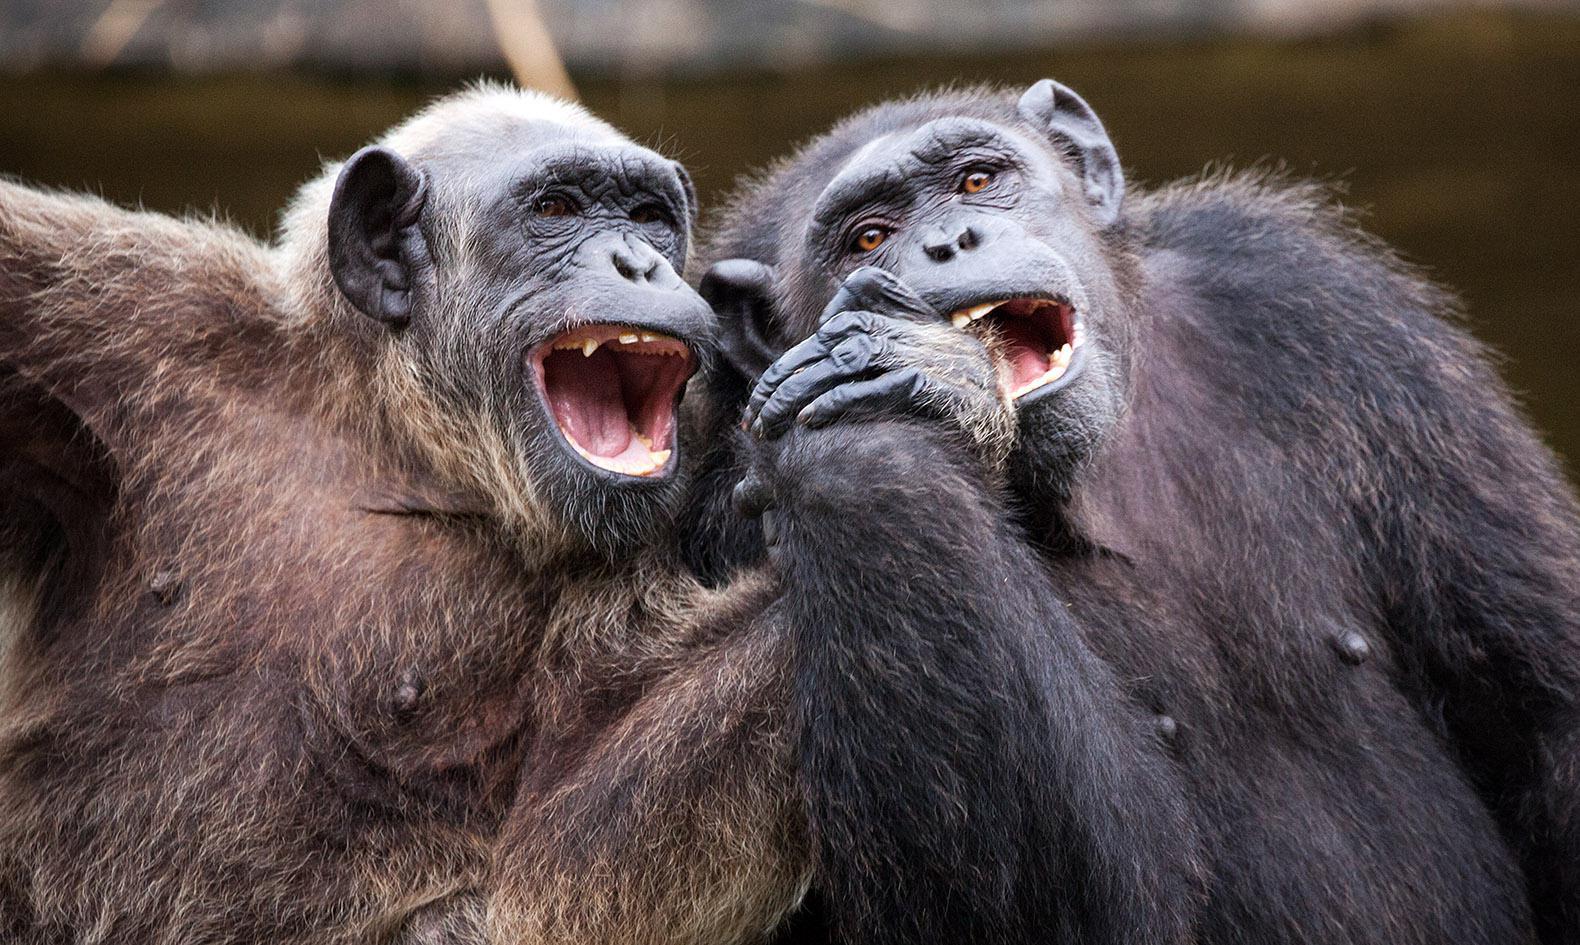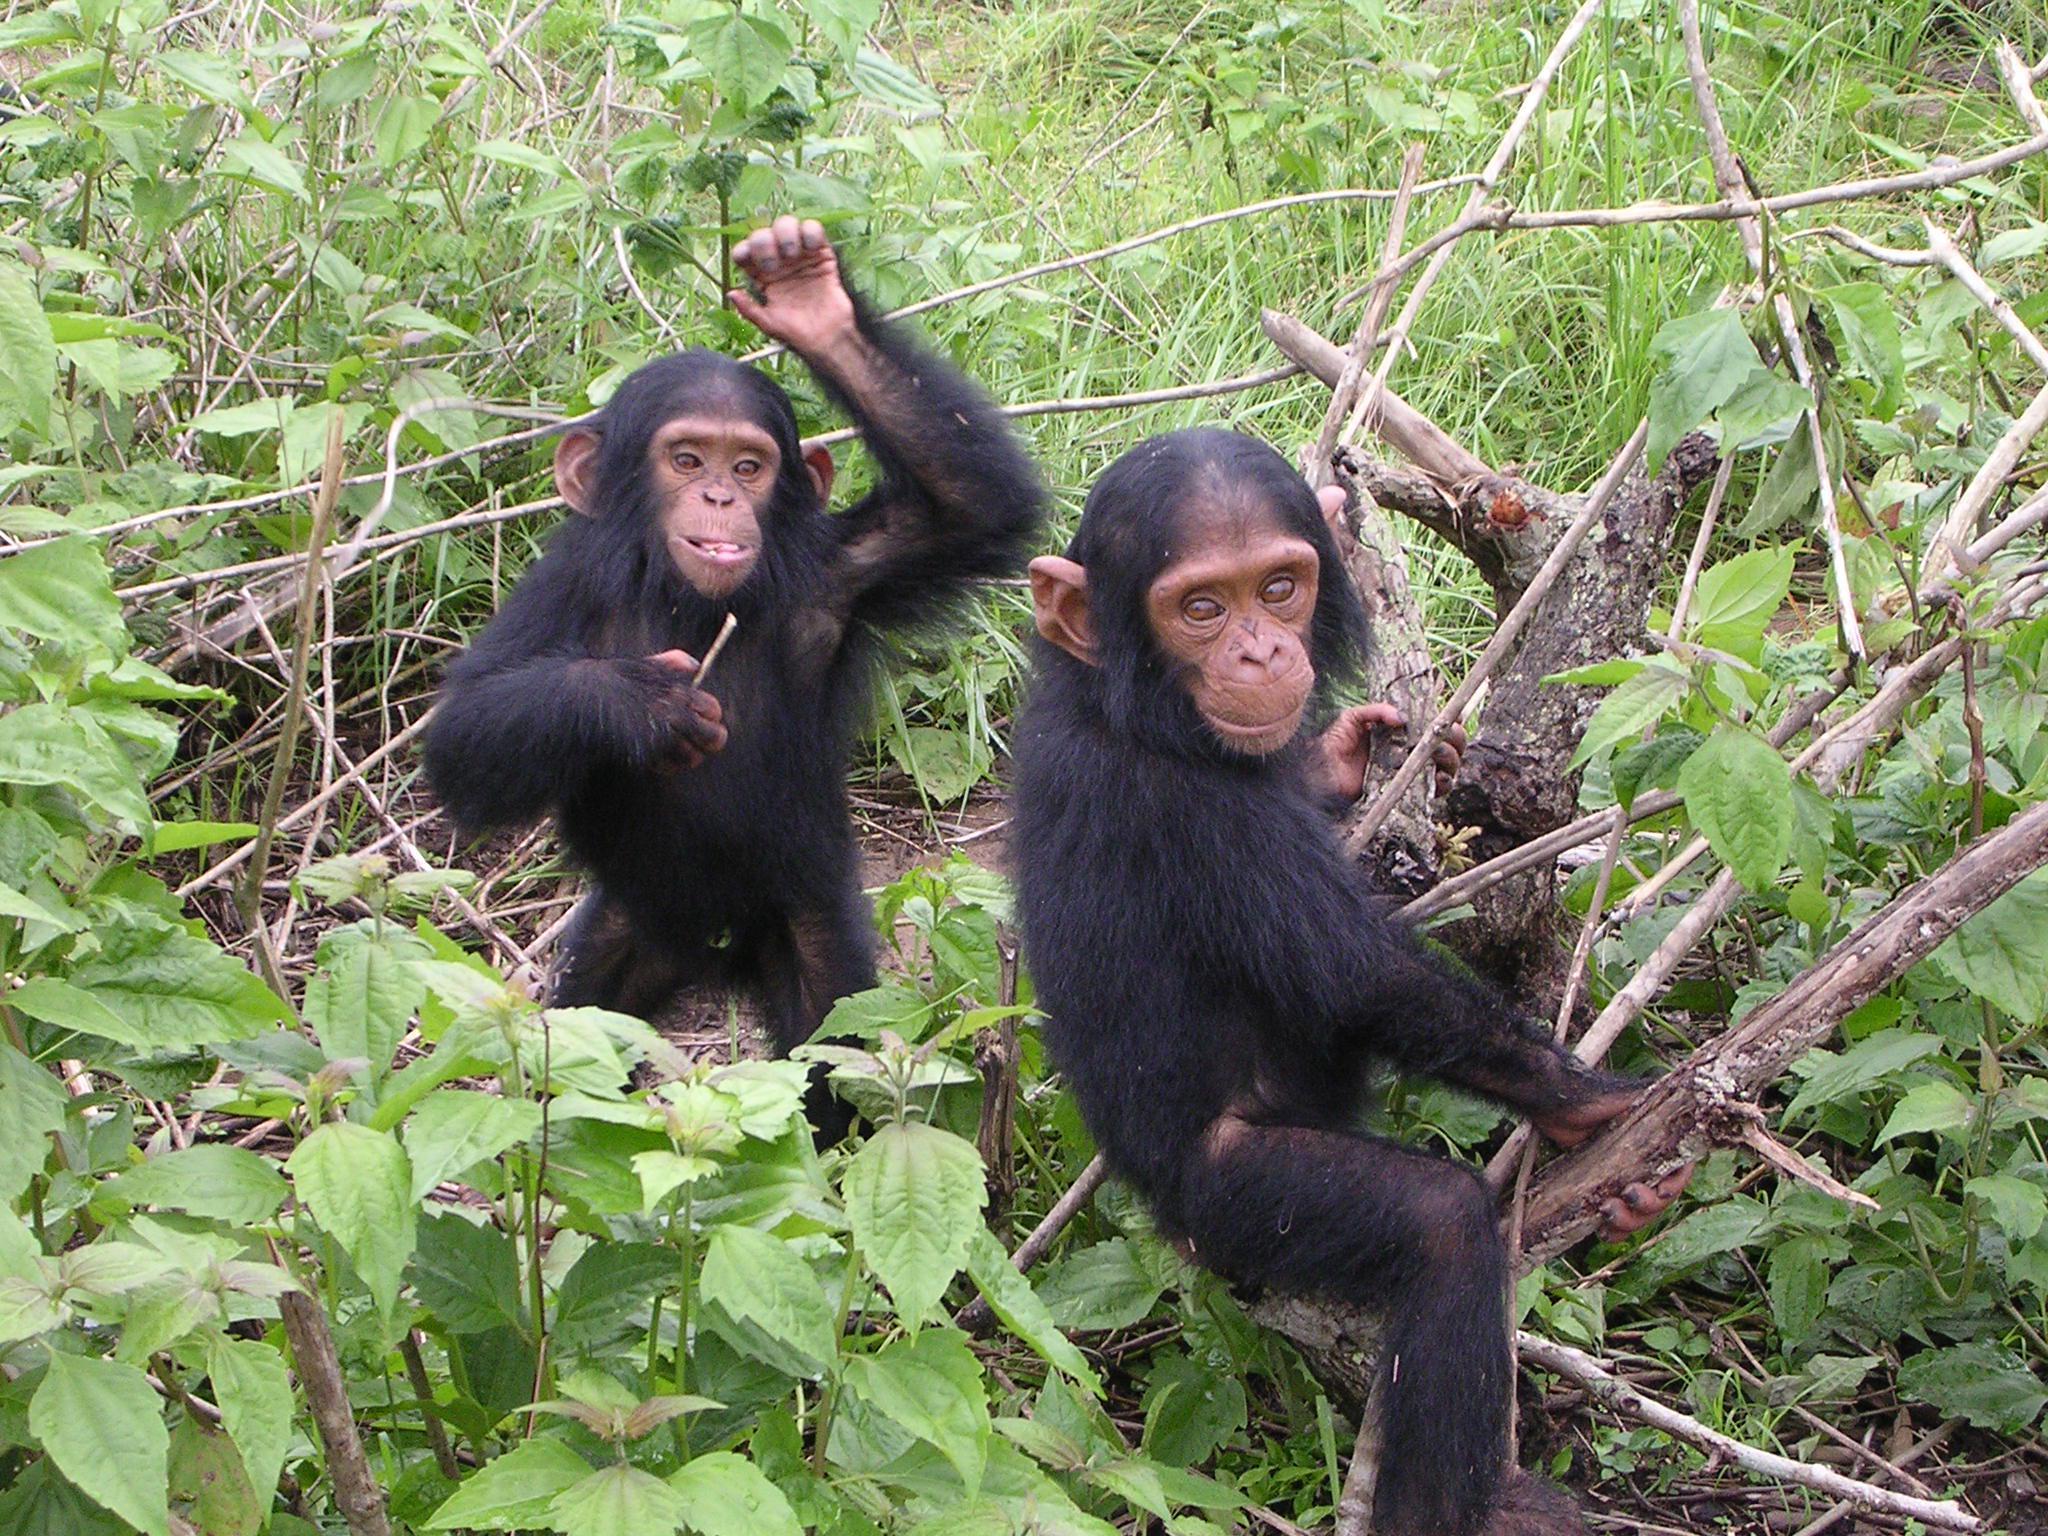The first image is the image on the left, the second image is the image on the right. Analyze the images presented: Is the assertion "The chimp on the left has both arms extended to grasp the chimp on the right in an image." valid? Answer yes or no. No. The first image is the image on the left, the second image is the image on the right. Given the left and right images, does the statement "Each image has two primates in the wild." hold true? Answer yes or no. Yes. 